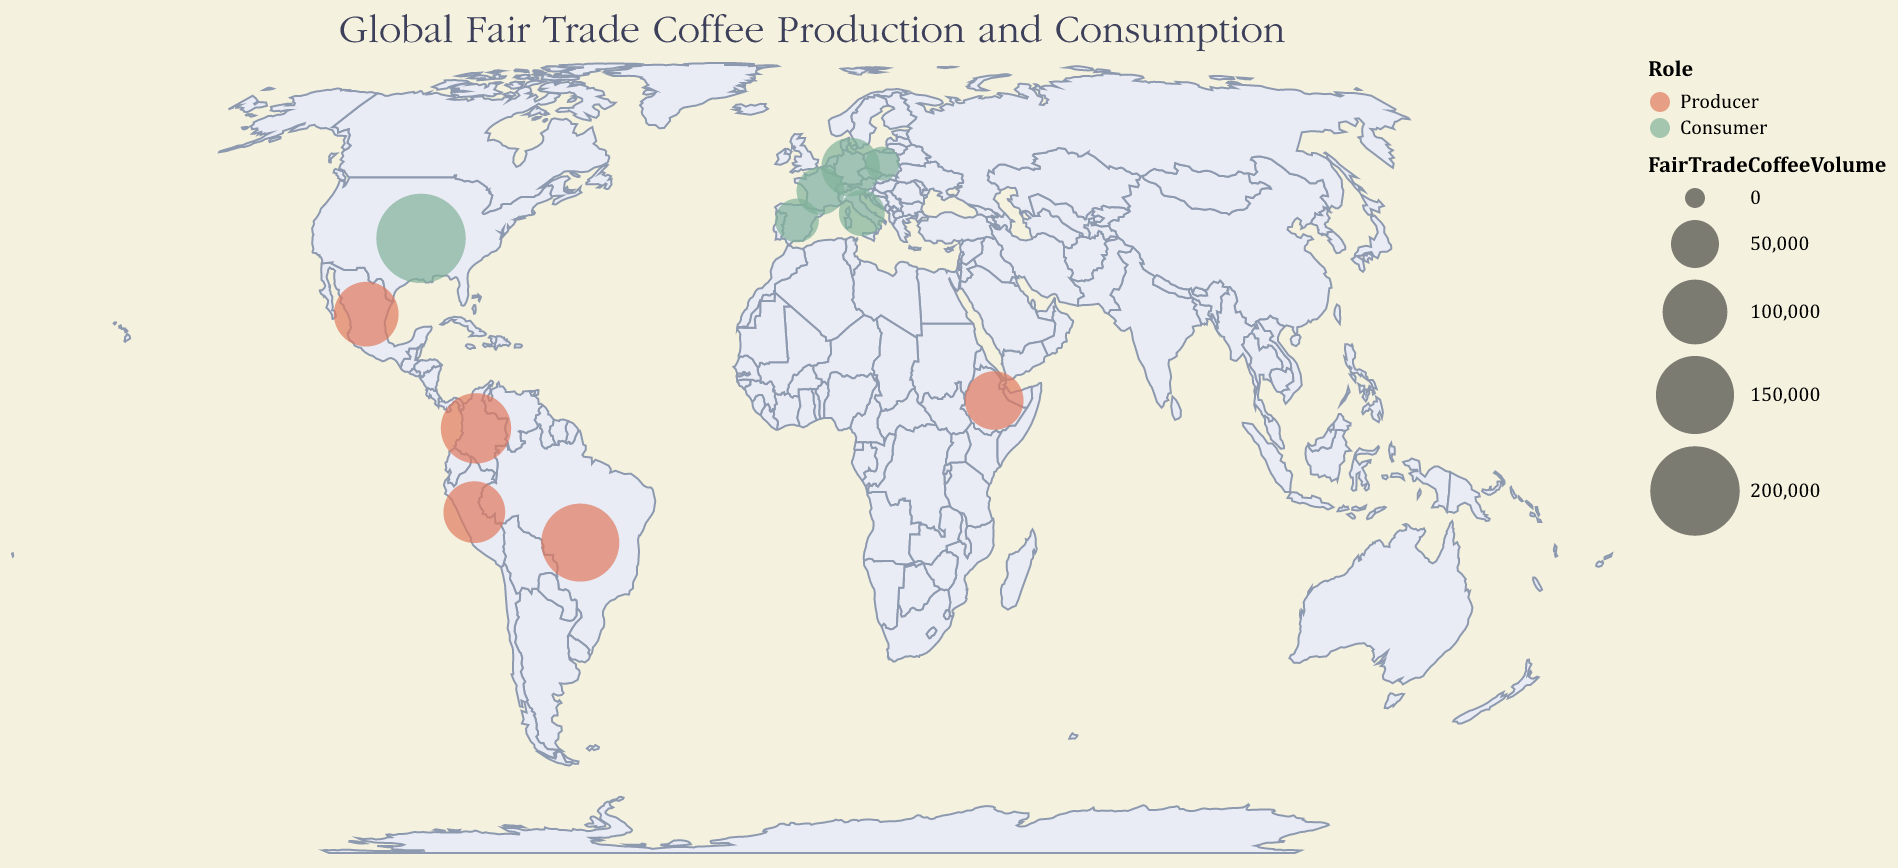What is the title of the map? The title can be found at the top of the visualization.
Answer: Global Fair Trade Coffee Production and Consumption How many countries are listed as coffee producers in the map? To find this, count the data points that have the role of "Producer".
Answer: 5 Which country has the most significant fair trade coffee consumption? By looking at the size of the circles and the tooltip information, find the country with the largest circle for consumers.
Answer: USA Which has a higher fair trade coffee volume, Germany or France? Compare the sizes and tooltip data for Germany and France.
Answer: Germany How does the Catholic population in Mexico compare to that in Colombia? Use the tooltip information to compare the Catholic populations of Mexico and Colombia.
Answer: Mexico has a higher Catholic population What is the total volume of fair trade coffee produced by all the producing countries? Sum the coffee volumes for all producer countries: Brazil (150,000), Colombia (120,000), Ethiopia (80,000), Mexico (100,000), and Peru (90,000).
Answer: 540,000 Which country has the smallest fair trade coffee consumption, and what is its volume? Look for the smallest consumer circle and check the tooltip for the country and volume.
Answer: Poland, 20,000 What geographical feature is used to project the map? Check the given projection type mentioned in the description of the visualization.
Answer: equalEarth Compare the economic justice initiatives of Brazil and Ethiopia in terms of the organizations involved. Check the tooltip data for both Brazil and Ethiopia to note the respective economic justice initiatives and organizations.
Answer: Caritas Brazil Fair Trade Program vs. Catholic Relief Services Ethiopia How does the fair trade coffee production volume of Peru compare to that of Colombia and what is the difference? Subtract Peru’s coffee volume (90,000) from Colombia’s coffee volume (120,000).
Answer: Colombia produces 30,000 more 